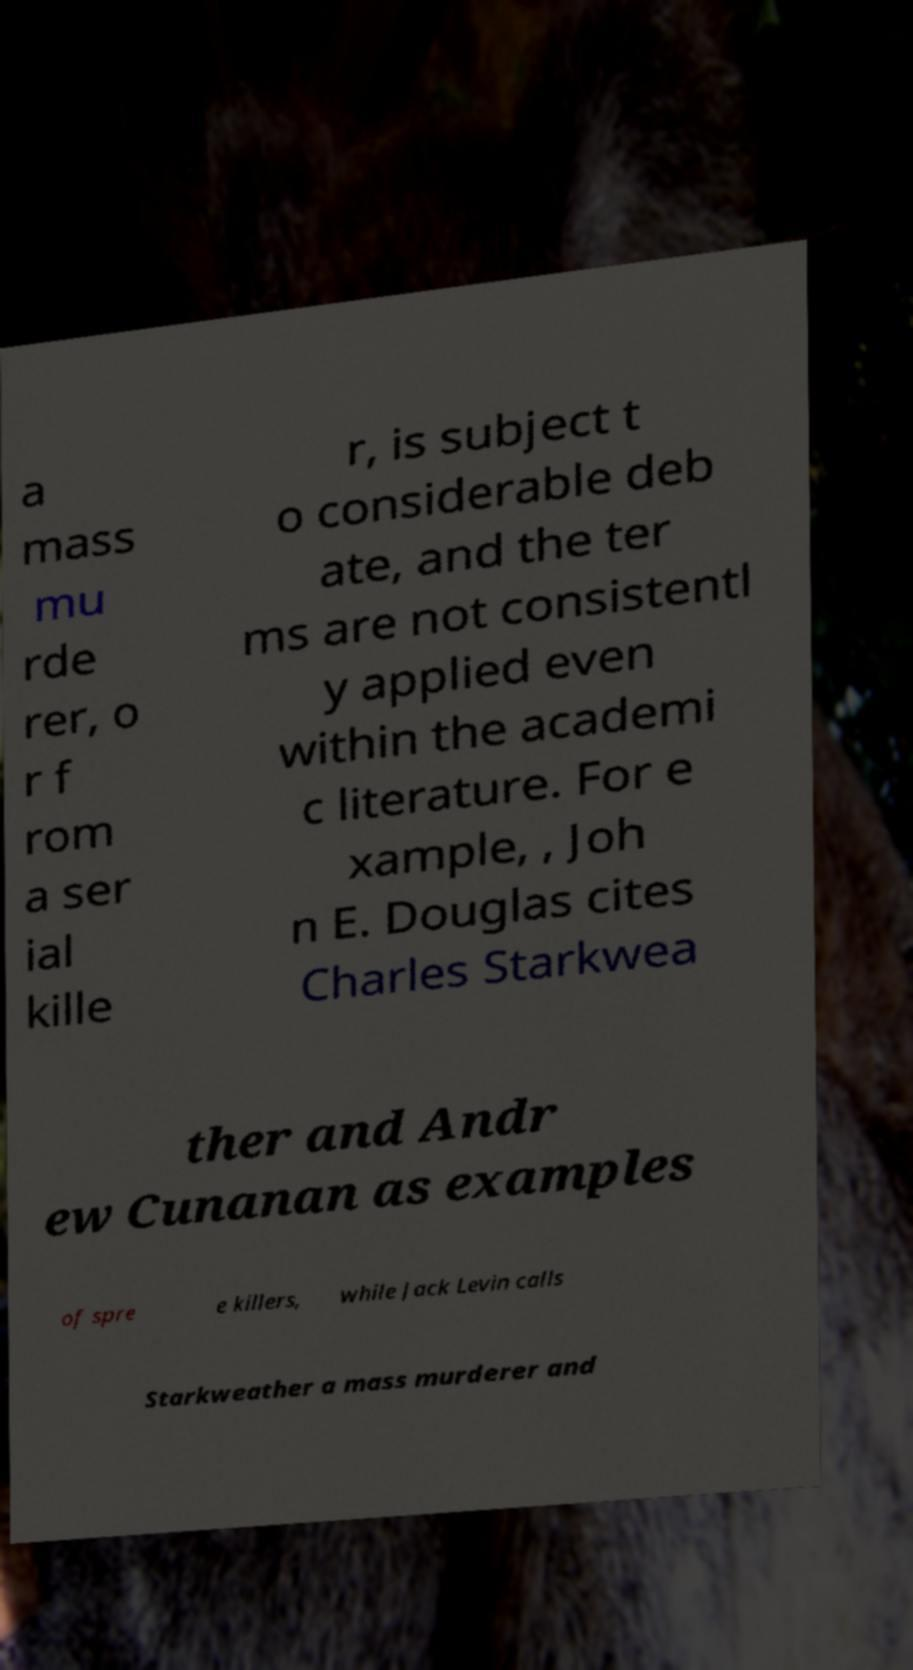Could you assist in decoding the text presented in this image and type it out clearly? a mass mu rde rer, o r f rom a ser ial kille r, is subject t o considerable deb ate, and the ter ms are not consistentl y applied even within the academi c literature. For e xample, , Joh n E. Douglas cites Charles Starkwea ther and Andr ew Cunanan as examples of spre e killers, while Jack Levin calls Starkweather a mass murderer and 